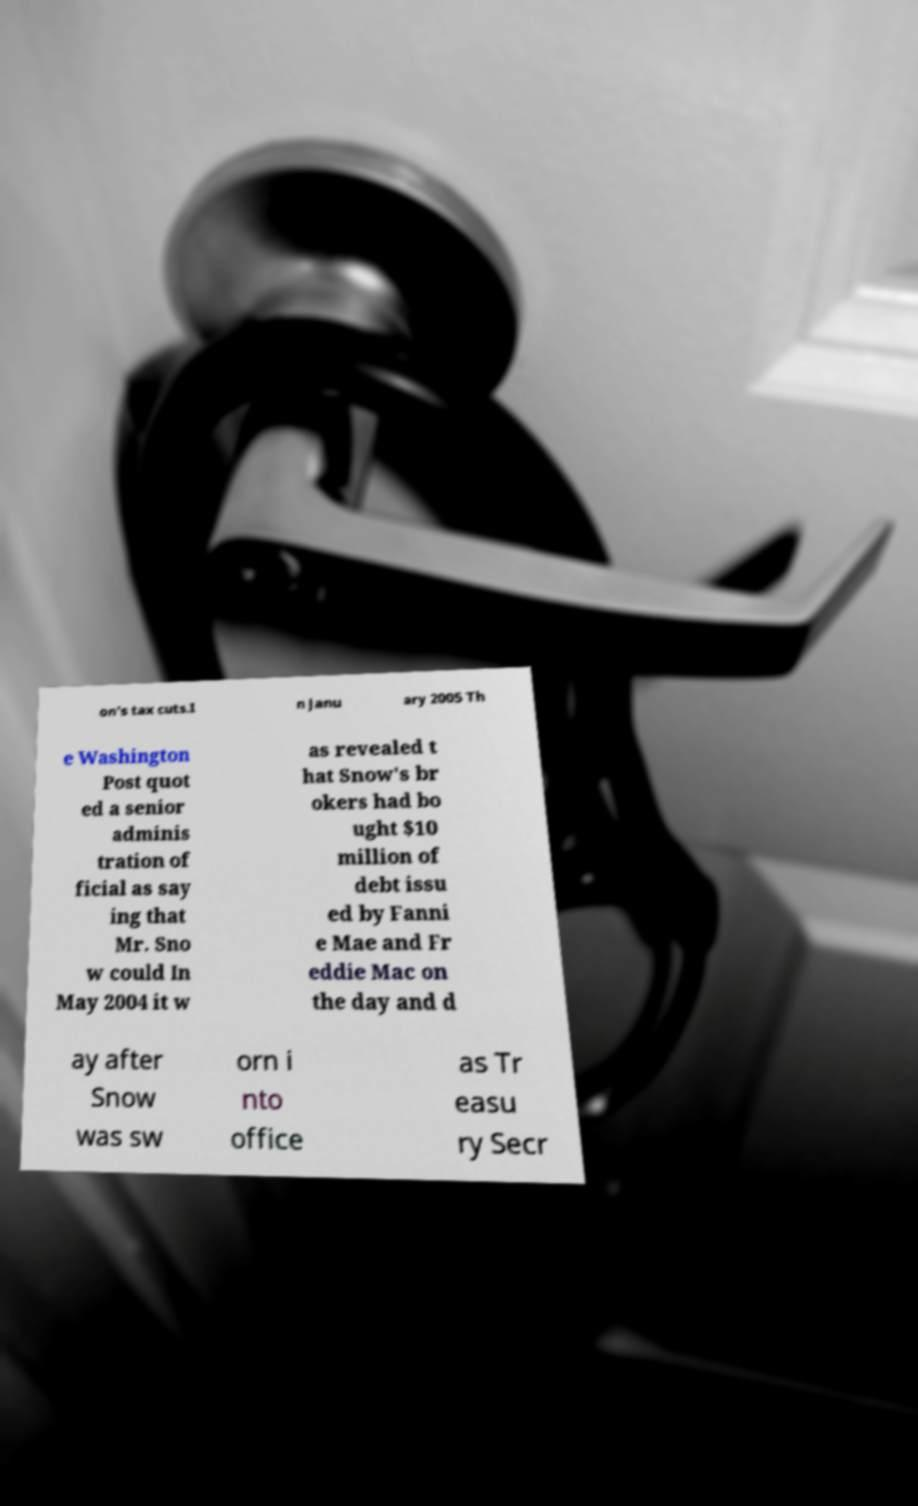For documentation purposes, I need the text within this image transcribed. Could you provide that? on's tax cuts.I n Janu ary 2005 Th e Washington Post quot ed a senior adminis tration of ficial as say ing that Mr. Sno w could In May 2004 it w as revealed t hat Snow's br okers had bo ught $10 million of debt issu ed by Fanni e Mae and Fr eddie Mac on the day and d ay after Snow was sw orn i nto office as Tr easu ry Secr 